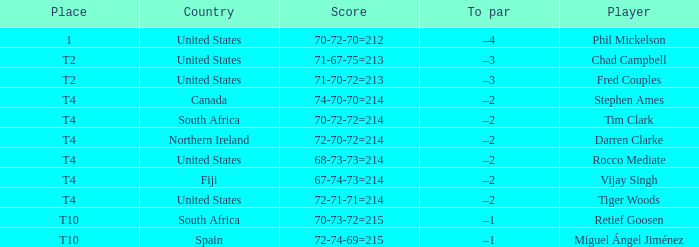What country is Chad Campbell from? United States. 